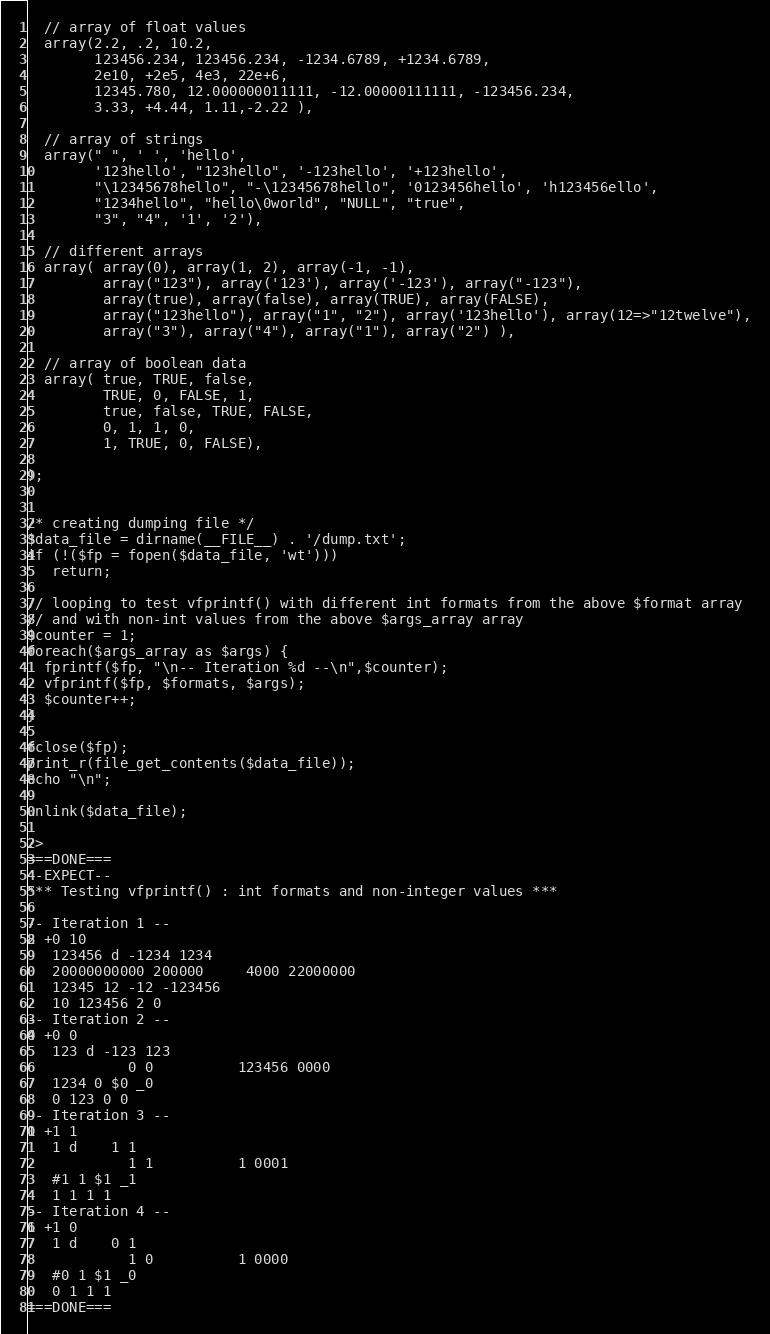Convert code to text. <code><loc_0><loc_0><loc_500><loc_500><_PHP_>
  // array of float values
  array(2.2, .2, 10.2,
        123456.234, 123456.234, -1234.6789, +1234.6789,
        2e10, +2e5, 4e3, 22e+6,
        12345.780, 12.000000011111, -12.00000111111, -123456.234,
        3.33, +4.44, 1.11,-2.22 ),

  // array of strings
  array(" ", ' ', 'hello',
        '123hello', "123hello", '-123hello', '+123hello',
        "\12345678hello", "-\12345678hello", '0123456hello', 'h123456ello',
        "1234hello", "hello\0world", "NULL", "true",
        "3", "4", '1', '2'),

  // different arrays
  array( array(0), array(1, 2), array(-1, -1),
         array("123"), array('123'), array('-123'), array("-123"),
         array(true), array(false), array(TRUE), array(FALSE),
         array("123hello"), array("1", "2"), array('123hello'), array(12=>"12twelve"),
         array("3"), array("4"), array("1"), array("2") ),

  // array of boolean data
  array( true, TRUE, false,
         TRUE, 0, FALSE, 1,
         true, false, TRUE, FALSE,
         0, 1, 1, 0,
         1, TRUE, 0, FALSE),
  
);


/* creating dumping file */
$data_file = dirname(__FILE__) . '/dump.txt';
if (!($fp = fopen($data_file, 'wt')))
   return;

// looping to test vfprintf() with different int formats from the above $format array
// and with non-int values from the above $args_array array
$counter = 1;
foreach($args_array as $args) {
  fprintf($fp, "\n-- Iteration %d --\n",$counter);
  vfprintf($fp, $formats, $args);
  $counter++;
}

fclose($fp);
print_r(file_get_contents($data_file));
echo "\n";

unlink($data_file);

?>
===DONE===
--EXPECT--
*** Testing vfprintf() : int formats and non-integer values ***

-- Iteration 1 --
2 +0 10 
   123456 d -1234 1234
   20000000000 200000     4000 22000000
   12345 12 -12 -123456
   10 123456 2 0
-- Iteration 2 --
0 +0 0 
   123 d -123 123 
            0 0          123456 0000
   1234 0 $0 _0
   0 123 0 0
-- Iteration 3 --
1 +1 1 
   1 d    1 1   
            1 1          1 0001
   #1 1 $1 _1
   1 1 1 1
-- Iteration 4 --
1 +1 0 
   1 d    0 1   
            1 0          1 0000
   #0 1 $1 _0
   0 1 1 1
===DONE===
</code> 